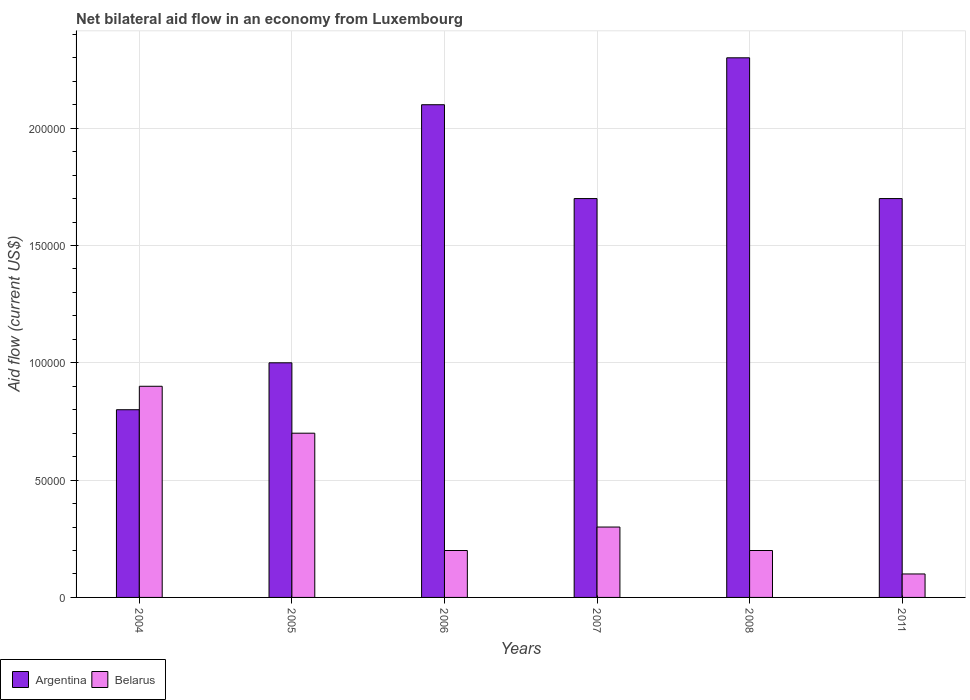How many different coloured bars are there?
Your response must be concise. 2. How many groups of bars are there?
Your answer should be very brief. 6. Are the number of bars on each tick of the X-axis equal?
Make the answer very short. Yes. How many bars are there on the 4th tick from the left?
Keep it short and to the point. 2. How many bars are there on the 1st tick from the right?
Keep it short and to the point. 2. What is the net bilateral aid flow in Belarus in 2004?
Keep it short and to the point. 9.00e+04. Across all years, what is the maximum net bilateral aid flow in Argentina?
Make the answer very short. 2.30e+05. What is the total net bilateral aid flow in Argentina in the graph?
Offer a terse response. 9.60e+05. What is the difference between the net bilateral aid flow in Argentina in 2007 and the net bilateral aid flow in Belarus in 2011?
Offer a very short reply. 1.60e+05. What is the ratio of the net bilateral aid flow in Belarus in 2004 to that in 2007?
Make the answer very short. 3. What is the difference between the highest and the second highest net bilateral aid flow in Belarus?
Provide a succinct answer. 2.00e+04. What is the difference between the highest and the lowest net bilateral aid flow in Argentina?
Keep it short and to the point. 1.50e+05. In how many years, is the net bilateral aid flow in Argentina greater than the average net bilateral aid flow in Argentina taken over all years?
Offer a very short reply. 4. Is the sum of the net bilateral aid flow in Argentina in 2005 and 2008 greater than the maximum net bilateral aid flow in Belarus across all years?
Offer a very short reply. Yes. What does the 2nd bar from the right in 2006 represents?
Offer a very short reply. Argentina. Are all the bars in the graph horizontal?
Make the answer very short. No. Are the values on the major ticks of Y-axis written in scientific E-notation?
Your answer should be compact. No. Does the graph contain any zero values?
Offer a very short reply. No. Does the graph contain grids?
Your answer should be very brief. Yes. How are the legend labels stacked?
Offer a very short reply. Horizontal. What is the title of the graph?
Give a very brief answer. Net bilateral aid flow in an economy from Luxembourg. What is the label or title of the X-axis?
Your answer should be compact. Years. What is the label or title of the Y-axis?
Provide a short and direct response. Aid flow (current US$). What is the Aid flow (current US$) in Argentina in 2004?
Keep it short and to the point. 8.00e+04. What is the Aid flow (current US$) of Belarus in 2004?
Provide a short and direct response. 9.00e+04. What is the Aid flow (current US$) in Argentina in 2005?
Your response must be concise. 1.00e+05. What is the Aid flow (current US$) of Belarus in 2005?
Offer a terse response. 7.00e+04. What is the Aid flow (current US$) of Belarus in 2006?
Make the answer very short. 2.00e+04. What is the Aid flow (current US$) in Belarus in 2007?
Give a very brief answer. 3.00e+04. What is the Aid flow (current US$) of Belarus in 2011?
Your response must be concise. 10000. What is the total Aid flow (current US$) in Argentina in the graph?
Your response must be concise. 9.60e+05. What is the difference between the Aid flow (current US$) in Argentina in 2004 and that in 2007?
Provide a succinct answer. -9.00e+04. What is the difference between the Aid flow (current US$) in Belarus in 2004 and that in 2007?
Your answer should be compact. 6.00e+04. What is the difference between the Aid flow (current US$) in Argentina in 2004 and that in 2008?
Your response must be concise. -1.50e+05. What is the difference between the Aid flow (current US$) in Argentina in 2004 and that in 2011?
Your response must be concise. -9.00e+04. What is the difference between the Aid flow (current US$) of Belarus in 2004 and that in 2011?
Offer a terse response. 8.00e+04. What is the difference between the Aid flow (current US$) in Belarus in 2005 and that in 2006?
Give a very brief answer. 5.00e+04. What is the difference between the Aid flow (current US$) of Argentina in 2005 and that in 2007?
Your response must be concise. -7.00e+04. What is the difference between the Aid flow (current US$) of Argentina in 2005 and that in 2011?
Give a very brief answer. -7.00e+04. What is the difference between the Aid flow (current US$) in Belarus in 2005 and that in 2011?
Ensure brevity in your answer.  6.00e+04. What is the difference between the Aid flow (current US$) in Argentina in 2006 and that in 2007?
Ensure brevity in your answer.  4.00e+04. What is the difference between the Aid flow (current US$) of Belarus in 2006 and that in 2008?
Your response must be concise. 0. What is the difference between the Aid flow (current US$) of Argentina in 2006 and that in 2011?
Provide a short and direct response. 4.00e+04. What is the difference between the Aid flow (current US$) of Belarus in 2007 and that in 2008?
Ensure brevity in your answer.  10000. What is the difference between the Aid flow (current US$) of Argentina in 2007 and that in 2011?
Provide a succinct answer. 0. What is the difference between the Aid flow (current US$) of Belarus in 2007 and that in 2011?
Offer a terse response. 2.00e+04. What is the difference between the Aid flow (current US$) of Belarus in 2008 and that in 2011?
Offer a terse response. 10000. What is the difference between the Aid flow (current US$) of Argentina in 2004 and the Aid flow (current US$) of Belarus in 2005?
Provide a succinct answer. 10000. What is the difference between the Aid flow (current US$) of Argentina in 2004 and the Aid flow (current US$) of Belarus in 2006?
Keep it short and to the point. 6.00e+04. What is the difference between the Aid flow (current US$) in Argentina in 2004 and the Aid flow (current US$) in Belarus in 2008?
Your answer should be very brief. 6.00e+04. What is the difference between the Aid flow (current US$) of Argentina in 2005 and the Aid flow (current US$) of Belarus in 2006?
Your answer should be compact. 8.00e+04. What is the difference between the Aid flow (current US$) in Argentina in 2006 and the Aid flow (current US$) in Belarus in 2008?
Ensure brevity in your answer.  1.90e+05. In the year 2004, what is the difference between the Aid flow (current US$) of Argentina and Aid flow (current US$) of Belarus?
Give a very brief answer. -10000. In the year 2005, what is the difference between the Aid flow (current US$) of Argentina and Aid flow (current US$) of Belarus?
Offer a very short reply. 3.00e+04. In the year 2007, what is the difference between the Aid flow (current US$) in Argentina and Aid flow (current US$) in Belarus?
Your response must be concise. 1.40e+05. In the year 2008, what is the difference between the Aid flow (current US$) of Argentina and Aid flow (current US$) of Belarus?
Provide a succinct answer. 2.10e+05. In the year 2011, what is the difference between the Aid flow (current US$) of Argentina and Aid flow (current US$) of Belarus?
Keep it short and to the point. 1.60e+05. What is the ratio of the Aid flow (current US$) in Argentina in 2004 to that in 2005?
Ensure brevity in your answer.  0.8. What is the ratio of the Aid flow (current US$) of Belarus in 2004 to that in 2005?
Your answer should be compact. 1.29. What is the ratio of the Aid flow (current US$) in Argentina in 2004 to that in 2006?
Your answer should be compact. 0.38. What is the ratio of the Aid flow (current US$) in Belarus in 2004 to that in 2006?
Provide a short and direct response. 4.5. What is the ratio of the Aid flow (current US$) of Argentina in 2004 to that in 2007?
Offer a very short reply. 0.47. What is the ratio of the Aid flow (current US$) in Belarus in 2004 to that in 2007?
Give a very brief answer. 3. What is the ratio of the Aid flow (current US$) of Argentina in 2004 to that in 2008?
Your response must be concise. 0.35. What is the ratio of the Aid flow (current US$) of Belarus in 2004 to that in 2008?
Provide a short and direct response. 4.5. What is the ratio of the Aid flow (current US$) in Argentina in 2004 to that in 2011?
Give a very brief answer. 0.47. What is the ratio of the Aid flow (current US$) of Belarus in 2004 to that in 2011?
Provide a succinct answer. 9. What is the ratio of the Aid flow (current US$) of Argentina in 2005 to that in 2006?
Make the answer very short. 0.48. What is the ratio of the Aid flow (current US$) in Belarus in 2005 to that in 2006?
Make the answer very short. 3.5. What is the ratio of the Aid flow (current US$) of Argentina in 2005 to that in 2007?
Make the answer very short. 0.59. What is the ratio of the Aid flow (current US$) in Belarus in 2005 to that in 2007?
Keep it short and to the point. 2.33. What is the ratio of the Aid flow (current US$) of Argentina in 2005 to that in 2008?
Provide a short and direct response. 0.43. What is the ratio of the Aid flow (current US$) in Argentina in 2005 to that in 2011?
Keep it short and to the point. 0.59. What is the ratio of the Aid flow (current US$) of Argentina in 2006 to that in 2007?
Your answer should be very brief. 1.24. What is the ratio of the Aid flow (current US$) of Belarus in 2006 to that in 2007?
Provide a short and direct response. 0.67. What is the ratio of the Aid flow (current US$) of Argentina in 2006 to that in 2011?
Your response must be concise. 1.24. What is the ratio of the Aid flow (current US$) in Belarus in 2006 to that in 2011?
Give a very brief answer. 2. What is the ratio of the Aid flow (current US$) in Argentina in 2007 to that in 2008?
Ensure brevity in your answer.  0.74. What is the ratio of the Aid flow (current US$) of Argentina in 2007 to that in 2011?
Provide a succinct answer. 1. What is the ratio of the Aid flow (current US$) of Belarus in 2007 to that in 2011?
Make the answer very short. 3. What is the ratio of the Aid flow (current US$) of Argentina in 2008 to that in 2011?
Provide a succinct answer. 1.35. What is the ratio of the Aid flow (current US$) in Belarus in 2008 to that in 2011?
Provide a short and direct response. 2. What is the difference between the highest and the second highest Aid flow (current US$) of Belarus?
Make the answer very short. 2.00e+04. What is the difference between the highest and the lowest Aid flow (current US$) of Argentina?
Your answer should be compact. 1.50e+05. What is the difference between the highest and the lowest Aid flow (current US$) of Belarus?
Make the answer very short. 8.00e+04. 